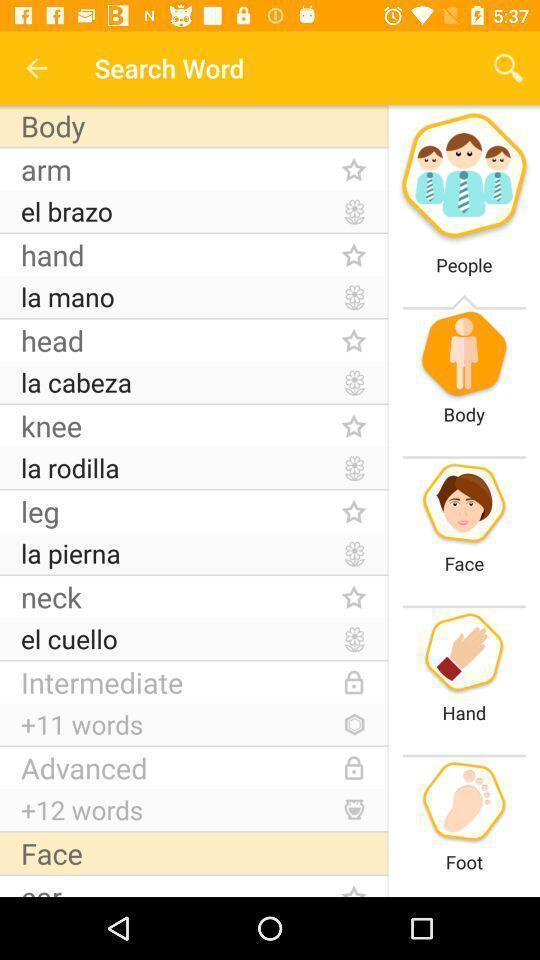Summarize the main components in this picture. Screen displaying the search bar of spanish learning app. 